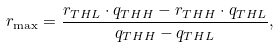Convert formula to latex. <formula><loc_0><loc_0><loc_500><loc_500>r _ { \max } = \frac { r _ { T H L } \cdot q _ { T H H } - r _ { T H H } \cdot q _ { T H L } } { q _ { T H H } - q _ { T H L } } ,</formula> 